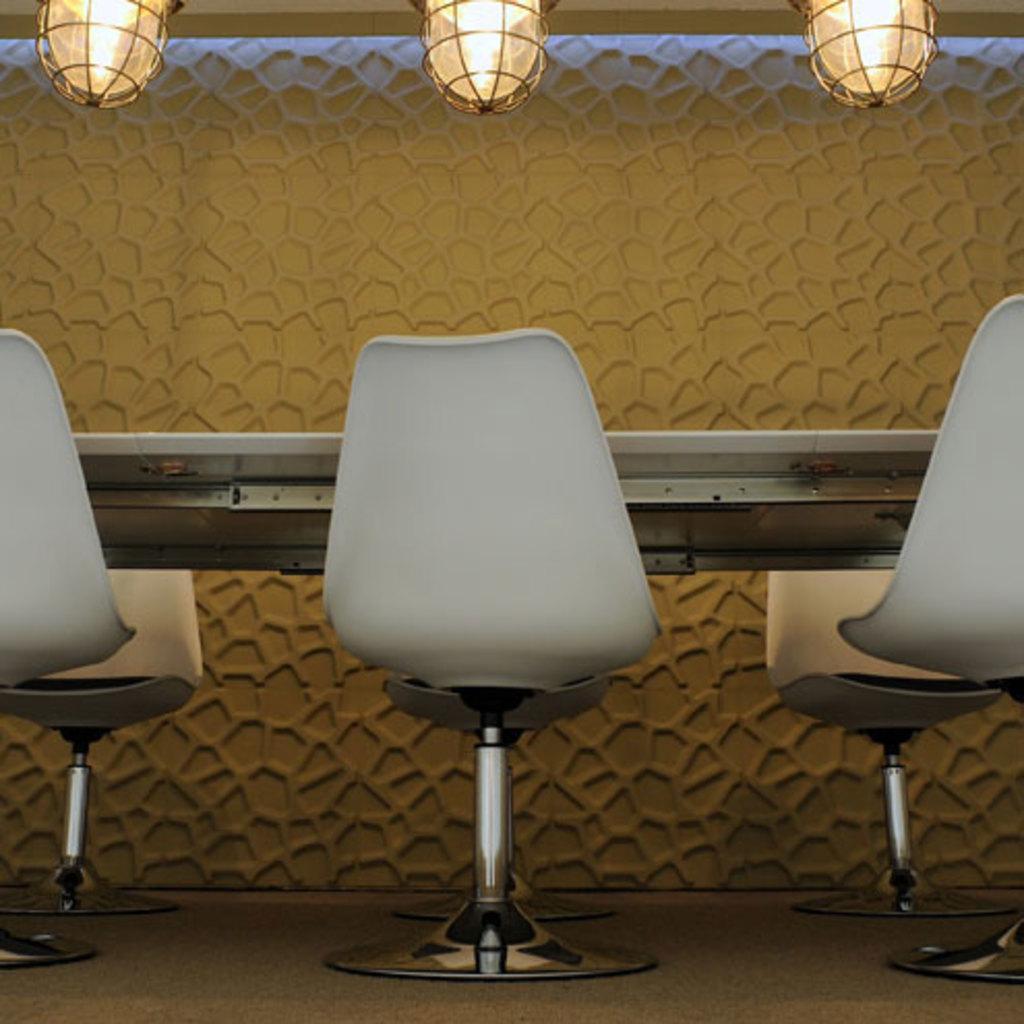Can you describe this image briefly? In this image I can see few chairs in white color, background I can see a table, few lights and the wall is in cream color. 